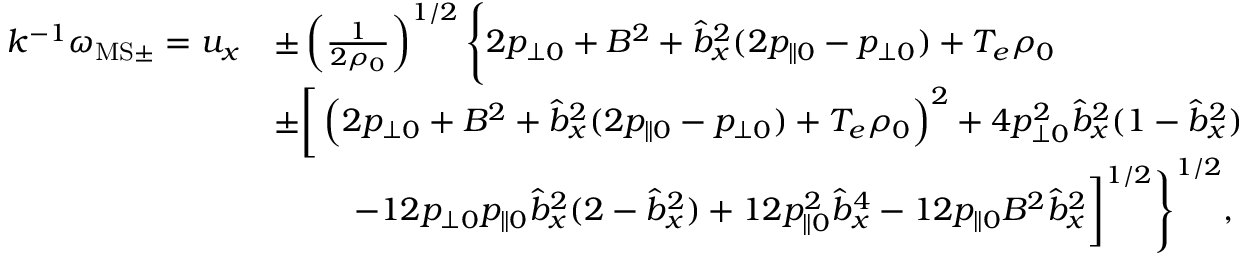<formula> <loc_0><loc_0><loc_500><loc_500>\begin{array} { r l } { k ^ { - 1 } \omega _ { M S \pm } = u _ { x } } & { \pm \left ( \frac { 1 } { 2 \rho _ { 0 } } \right ) ^ { 1 / 2 } \left \{ 2 p _ { \perp 0 } + B ^ { 2 } + \hat { b } _ { x } ^ { 2 } ( 2 p _ { \| 0 } - p _ { \perp 0 } ) + T _ { e } \rho _ { 0 } } \\ & { \pm \left [ \left ( 2 p _ { \perp 0 } + B ^ { 2 } + \hat { b } _ { x } ^ { 2 } ( 2 p _ { \| 0 } - p _ { \perp 0 } ) + T _ { e } \rho _ { 0 } \right ) ^ { 2 } + 4 p _ { \perp 0 } ^ { 2 } \hat { b } _ { x } ^ { 2 } ( 1 - \hat { b } _ { x } ^ { 2 } ) } \\ & { \quad \, - 1 2 p _ { \perp 0 } p _ { \| 0 } \hat { b } _ { x } ^ { 2 } ( 2 - \hat { b } _ { x } ^ { 2 } ) + 1 2 p _ { \| 0 } ^ { 2 } \hat { b } _ { x } ^ { 4 } - 1 2 p _ { \| 0 } B ^ { 2 } \hat { b } _ { x } ^ { 2 } \right ] ^ { 1 / 2 } \right \} ^ { 1 / 2 } , } \end{array}</formula> 